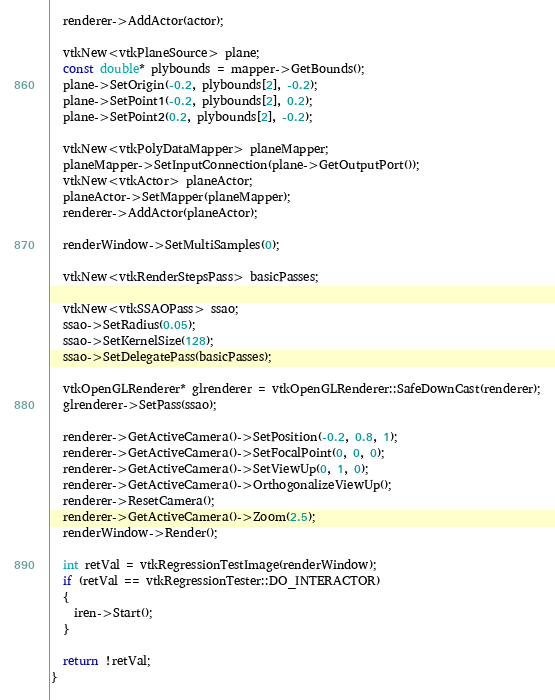<code> <loc_0><loc_0><loc_500><loc_500><_C++_>  renderer->AddActor(actor);

  vtkNew<vtkPlaneSource> plane;
  const double* plybounds = mapper->GetBounds();
  plane->SetOrigin(-0.2, plybounds[2], -0.2);
  plane->SetPoint1(-0.2, plybounds[2], 0.2);
  plane->SetPoint2(0.2, plybounds[2], -0.2);

  vtkNew<vtkPolyDataMapper> planeMapper;
  planeMapper->SetInputConnection(plane->GetOutputPort());
  vtkNew<vtkActor> planeActor;
  planeActor->SetMapper(planeMapper);
  renderer->AddActor(planeActor);

  renderWindow->SetMultiSamples(0);

  vtkNew<vtkRenderStepsPass> basicPasses;

  vtkNew<vtkSSAOPass> ssao;
  ssao->SetRadius(0.05);
  ssao->SetKernelSize(128);
  ssao->SetDelegatePass(basicPasses);

  vtkOpenGLRenderer* glrenderer = vtkOpenGLRenderer::SafeDownCast(renderer);
  glrenderer->SetPass(ssao);

  renderer->GetActiveCamera()->SetPosition(-0.2, 0.8, 1);
  renderer->GetActiveCamera()->SetFocalPoint(0, 0, 0);
  renderer->GetActiveCamera()->SetViewUp(0, 1, 0);
  renderer->GetActiveCamera()->OrthogonalizeViewUp();
  renderer->ResetCamera();
  renderer->GetActiveCamera()->Zoom(2.5);
  renderWindow->Render();

  int retVal = vtkRegressionTestImage(renderWindow);
  if (retVal == vtkRegressionTester::DO_INTERACTOR)
  {
    iren->Start();
  }

  return !retVal;
}
</code> 